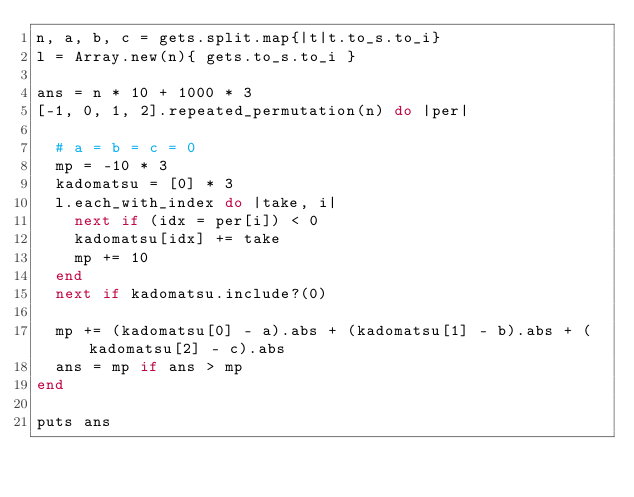Convert code to text. <code><loc_0><loc_0><loc_500><loc_500><_Ruby_>n, a, b, c = gets.split.map{|t|t.to_s.to_i}
l = Array.new(n){ gets.to_s.to_i }
 
ans = n * 10 + 1000 * 3
[-1, 0, 1, 2].repeated_permutation(n) do |per|
  
  # a = b = c = 0
  mp = -10 * 3
  kadomatsu = [0] * 3
  l.each_with_index do |take, i|
    next if (idx = per[i]) < 0
    kadomatsu[idx] += take
    mp += 10
  end
  next if kadomatsu.include?(0)
  
  mp += (kadomatsu[0] - a).abs + (kadomatsu[1] - b).abs + (kadomatsu[2] - c).abs
  ans = mp if ans > mp
end

puts ans</code> 